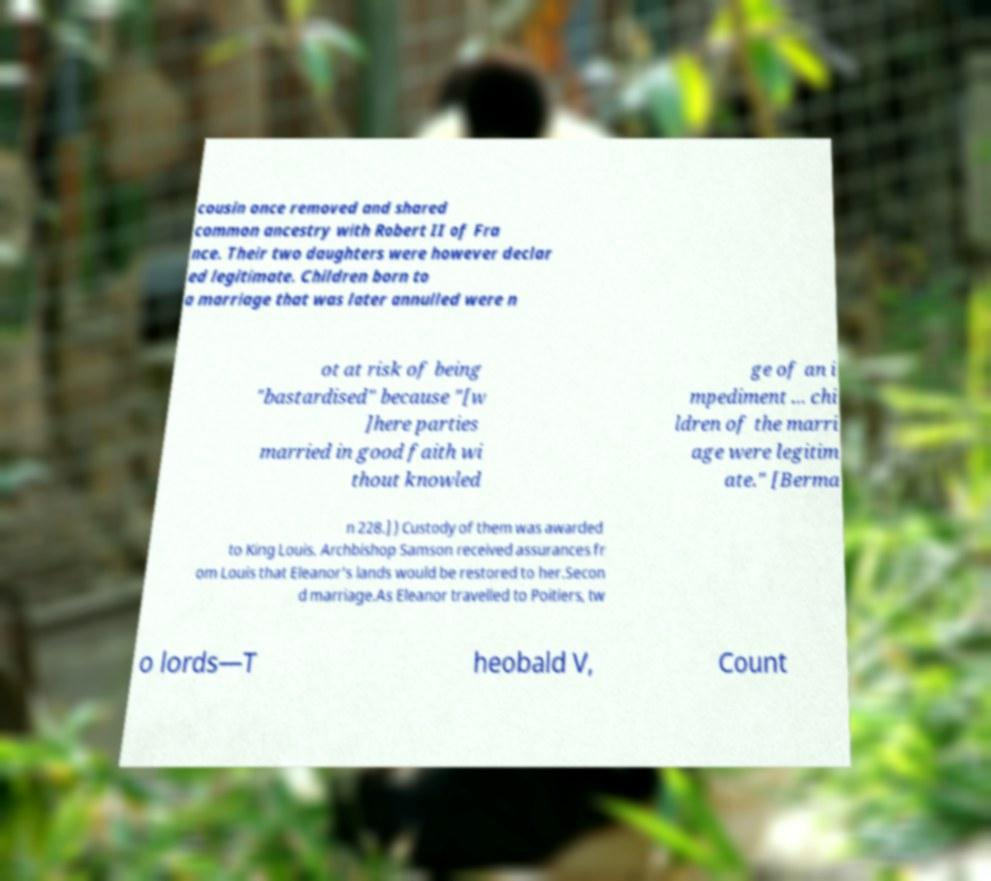Please identify and transcribe the text found in this image. cousin once removed and shared common ancestry with Robert II of Fra nce. Their two daughters were however declar ed legitimate. Children born to a marriage that was later annulled were n ot at risk of being "bastardised" because "[w ]here parties married in good faith wi thout knowled ge of an i mpediment ... chi ldren of the marri age were legitim ate." [Berma n 228.] ) Custody of them was awarded to King Louis. Archbishop Samson received assurances fr om Louis that Eleanor's lands would be restored to her.Secon d marriage.As Eleanor travelled to Poitiers, tw o lords—T heobald V, Count 